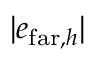<formula> <loc_0><loc_0><loc_500><loc_500>| e _ { f a r , h } |</formula> 